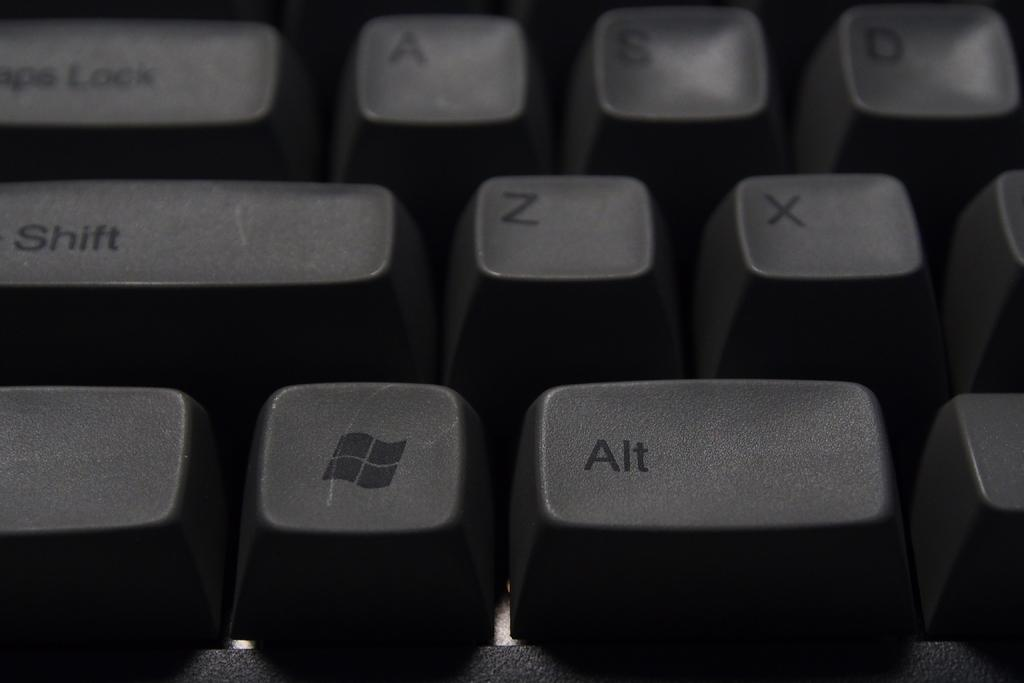<image>
Present a compact description of the photo's key features. Windows and Alt key are highlighted on this keyboard. 